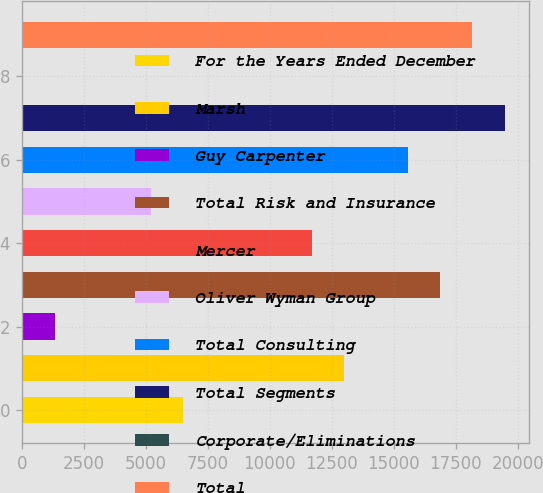Convert chart. <chart><loc_0><loc_0><loc_500><loc_500><bar_chart><fcel>For the Years Ended December<fcel>Marsh<fcel>Guy Carpenter<fcel>Total Risk and Insurance<fcel>Mercer<fcel>Oliver Wyman Group<fcel>Total Consulting<fcel>Total Segments<fcel>Corporate/Eliminations<fcel>Total<nl><fcel>6514.5<fcel>12990<fcel>1334.1<fcel>16875.3<fcel>11694.9<fcel>5219.4<fcel>15580.2<fcel>19465.5<fcel>39<fcel>18170.4<nl></chart> 